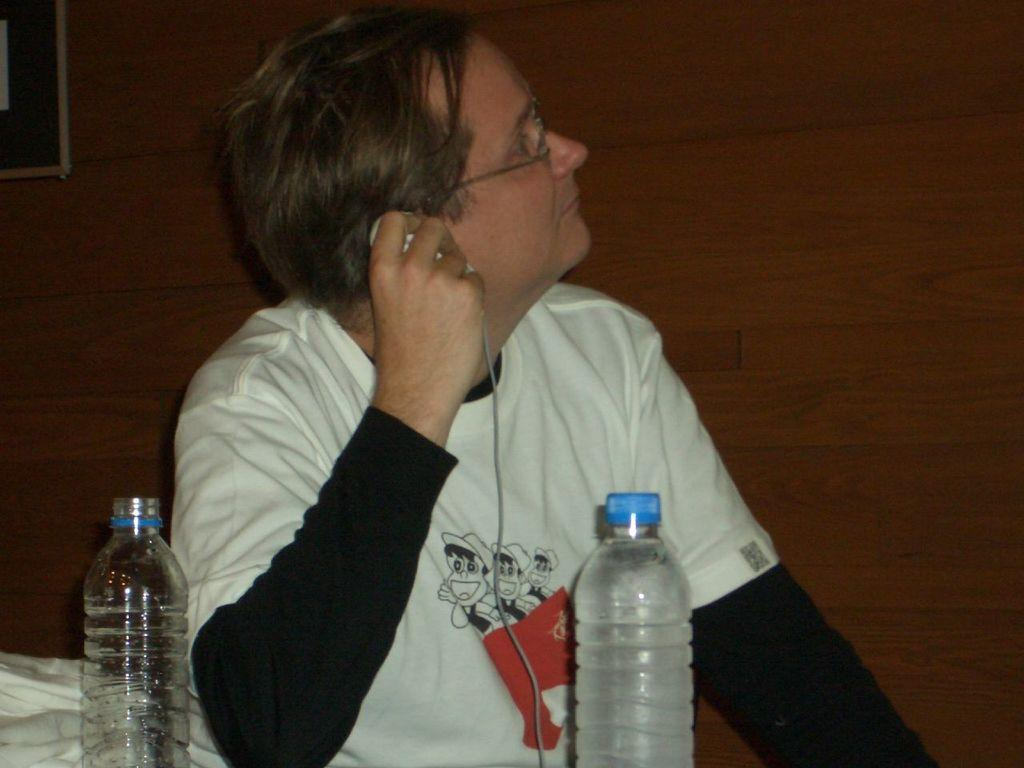How many people are in the group visible in the image? The transcript does not specify the number of people in the group, so we cannot determine that from the information provided. What are the people near the car doing? The transcript does not mention any specific actions or activities of the people, so we cannot determine that from the information provided. What type of building is visible in the background? The transcript does not describe the building in the background, so we cannot determine that from the information provided. Is there an advertisement for a lunchroom on the car in the image? There is no mention of an advertisement or a lunchroom in the transcript, so we cannot determine that from the information provided. Can you tell me if the people in the image are asking for help? The transcript does not mention any specific actions or activities of the people, so we cannot determine that from the information provided. 